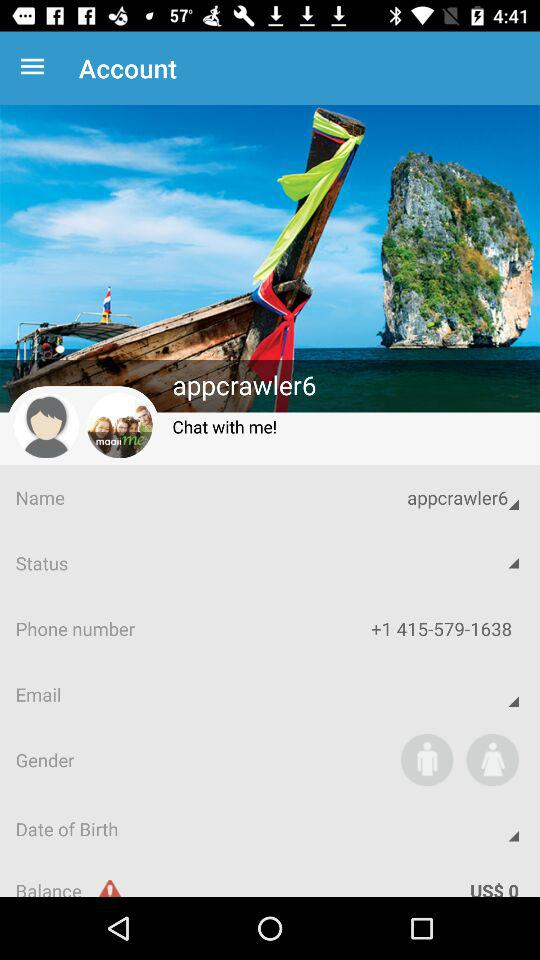What is the gender option? The gender options are "Male" and "Female". 